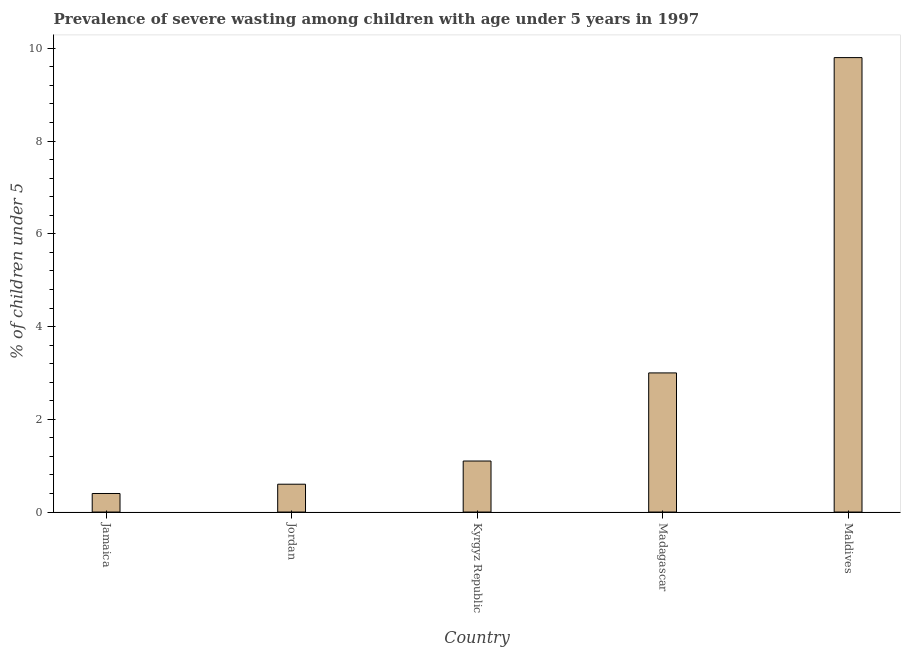Does the graph contain any zero values?
Your response must be concise. No. What is the title of the graph?
Your answer should be compact. Prevalence of severe wasting among children with age under 5 years in 1997. What is the label or title of the X-axis?
Your answer should be compact. Country. What is the label or title of the Y-axis?
Provide a succinct answer.  % of children under 5. What is the prevalence of severe wasting in Jordan?
Make the answer very short. 0.6. Across all countries, what is the maximum prevalence of severe wasting?
Ensure brevity in your answer.  9.8. Across all countries, what is the minimum prevalence of severe wasting?
Make the answer very short. 0.4. In which country was the prevalence of severe wasting maximum?
Offer a very short reply. Maldives. In which country was the prevalence of severe wasting minimum?
Offer a terse response. Jamaica. What is the sum of the prevalence of severe wasting?
Give a very brief answer. 14.9. What is the difference between the prevalence of severe wasting in Jordan and Madagascar?
Provide a short and direct response. -2.4. What is the average prevalence of severe wasting per country?
Ensure brevity in your answer.  2.98. What is the median prevalence of severe wasting?
Offer a terse response. 1.1. What is the ratio of the prevalence of severe wasting in Jamaica to that in Maldives?
Provide a succinct answer. 0.04. Is the sum of the prevalence of severe wasting in Kyrgyz Republic and Maldives greater than the maximum prevalence of severe wasting across all countries?
Provide a succinct answer. Yes. How many bars are there?
Keep it short and to the point. 5. Are all the bars in the graph horizontal?
Offer a terse response. No. What is the  % of children under 5 of Jamaica?
Provide a short and direct response. 0.4. What is the  % of children under 5 of Jordan?
Provide a succinct answer. 0.6. What is the  % of children under 5 in Kyrgyz Republic?
Provide a succinct answer. 1.1. What is the  % of children under 5 in Madagascar?
Provide a short and direct response. 3. What is the  % of children under 5 in Maldives?
Your answer should be compact. 9.8. What is the difference between the  % of children under 5 in Jamaica and Jordan?
Give a very brief answer. -0.2. What is the difference between the  % of children under 5 in Jamaica and Kyrgyz Republic?
Offer a terse response. -0.7. What is the difference between the  % of children under 5 in Jamaica and Maldives?
Offer a terse response. -9.4. What is the difference between the  % of children under 5 in Jordan and Madagascar?
Provide a short and direct response. -2.4. What is the difference between the  % of children under 5 in Kyrgyz Republic and Maldives?
Provide a short and direct response. -8.7. What is the ratio of the  % of children under 5 in Jamaica to that in Jordan?
Give a very brief answer. 0.67. What is the ratio of the  % of children under 5 in Jamaica to that in Kyrgyz Republic?
Ensure brevity in your answer.  0.36. What is the ratio of the  % of children under 5 in Jamaica to that in Madagascar?
Provide a short and direct response. 0.13. What is the ratio of the  % of children under 5 in Jamaica to that in Maldives?
Your answer should be very brief. 0.04. What is the ratio of the  % of children under 5 in Jordan to that in Kyrgyz Republic?
Your answer should be very brief. 0.55. What is the ratio of the  % of children under 5 in Jordan to that in Madagascar?
Make the answer very short. 0.2. What is the ratio of the  % of children under 5 in Jordan to that in Maldives?
Make the answer very short. 0.06. What is the ratio of the  % of children under 5 in Kyrgyz Republic to that in Madagascar?
Keep it short and to the point. 0.37. What is the ratio of the  % of children under 5 in Kyrgyz Republic to that in Maldives?
Your answer should be compact. 0.11. What is the ratio of the  % of children under 5 in Madagascar to that in Maldives?
Your answer should be very brief. 0.31. 